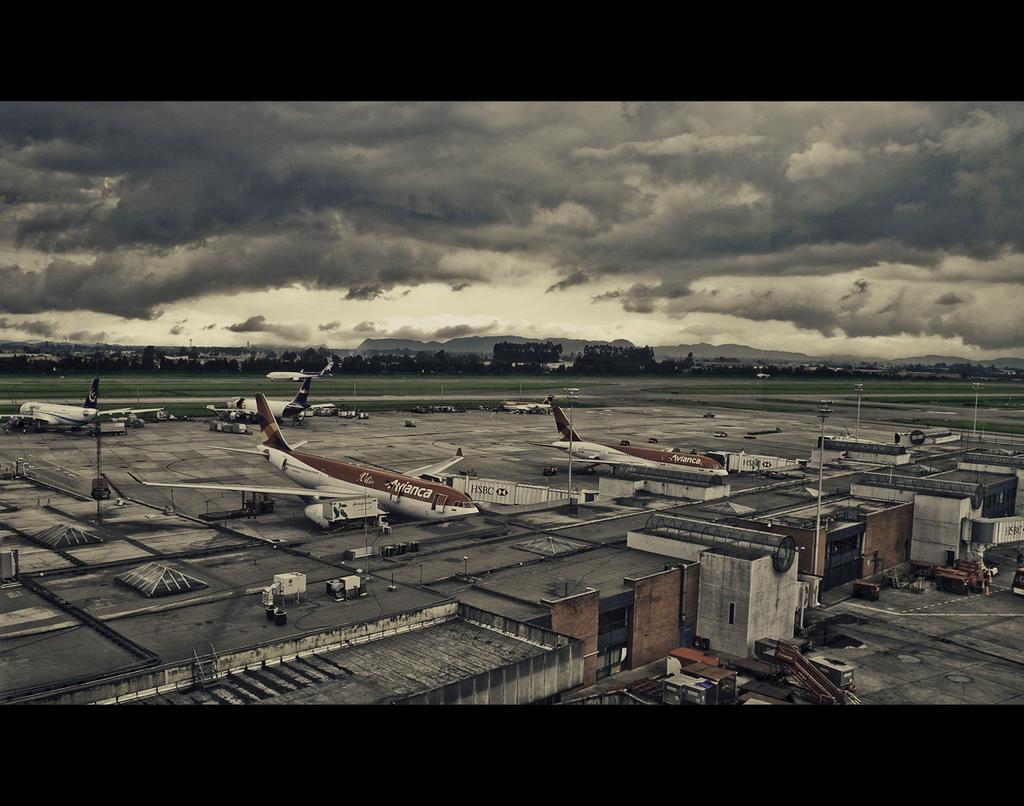Could you give a brief overview of what you see in this image? This picture seems to be an edited image with the borders. In the foreground we can see the buildings and some other objects. In the center we can see the vehicles and airplanes and we can see the objects placed on the ground. In the background we can see the sky which is full of clouds and we can see the grass and some other objects. 